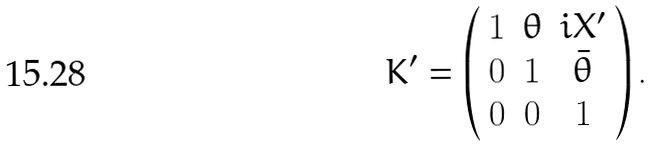Convert formula to latex. <formula><loc_0><loc_0><loc_500><loc_500>K ^ { \prime } = \left ( \begin{array} { c c c } { 1 } & { \theta } & { { i X ^ { \prime } } } \\ { 0 } & { 1 } & { { \bar { \theta } } } \\ { 0 } & { 0 } & { 1 } \end{array} \right ) .</formula> 